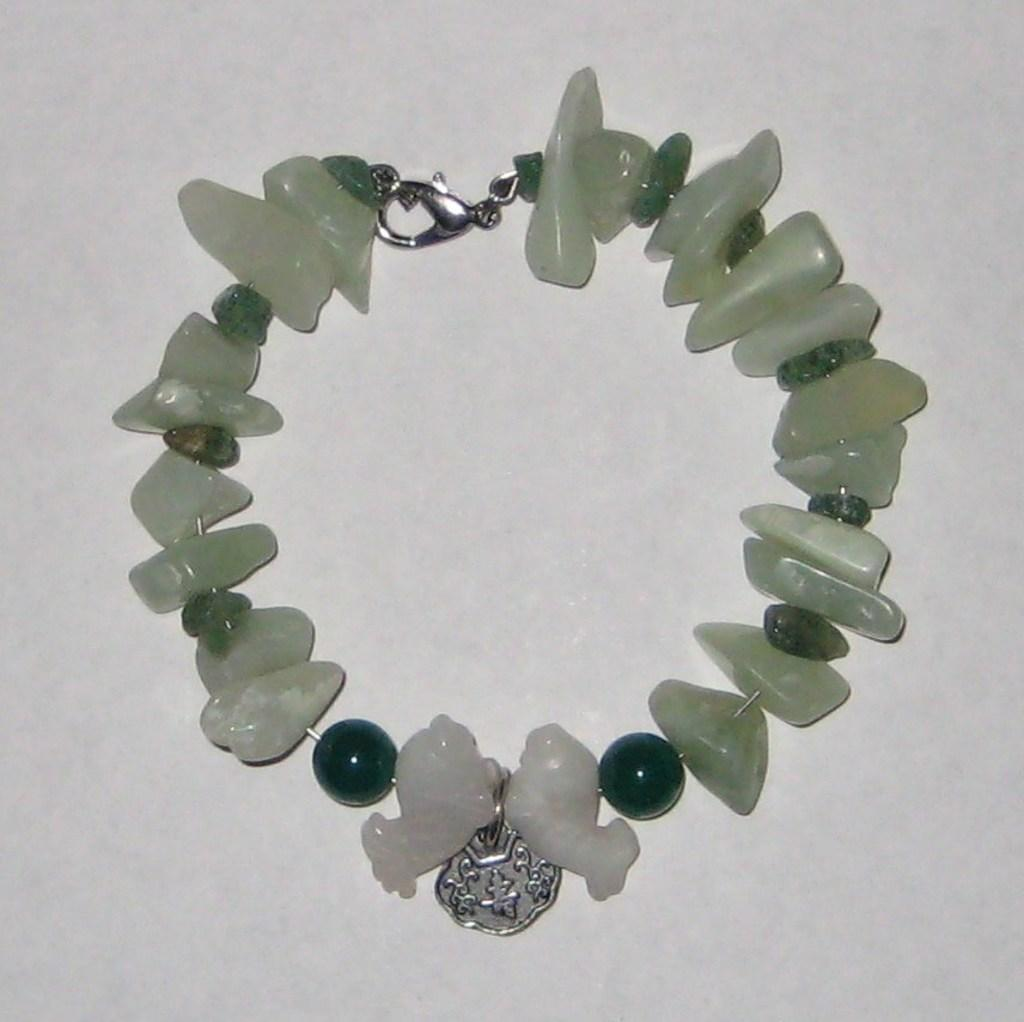What is the main object in the image? There is a bracelet in the image. What color is the background of the image? The background of the image is white. How many trucks are visible in the image? There are no trucks present in the image. What type of worm can be seen crawling on the bracelet in the image? There is no worm present in the image. 